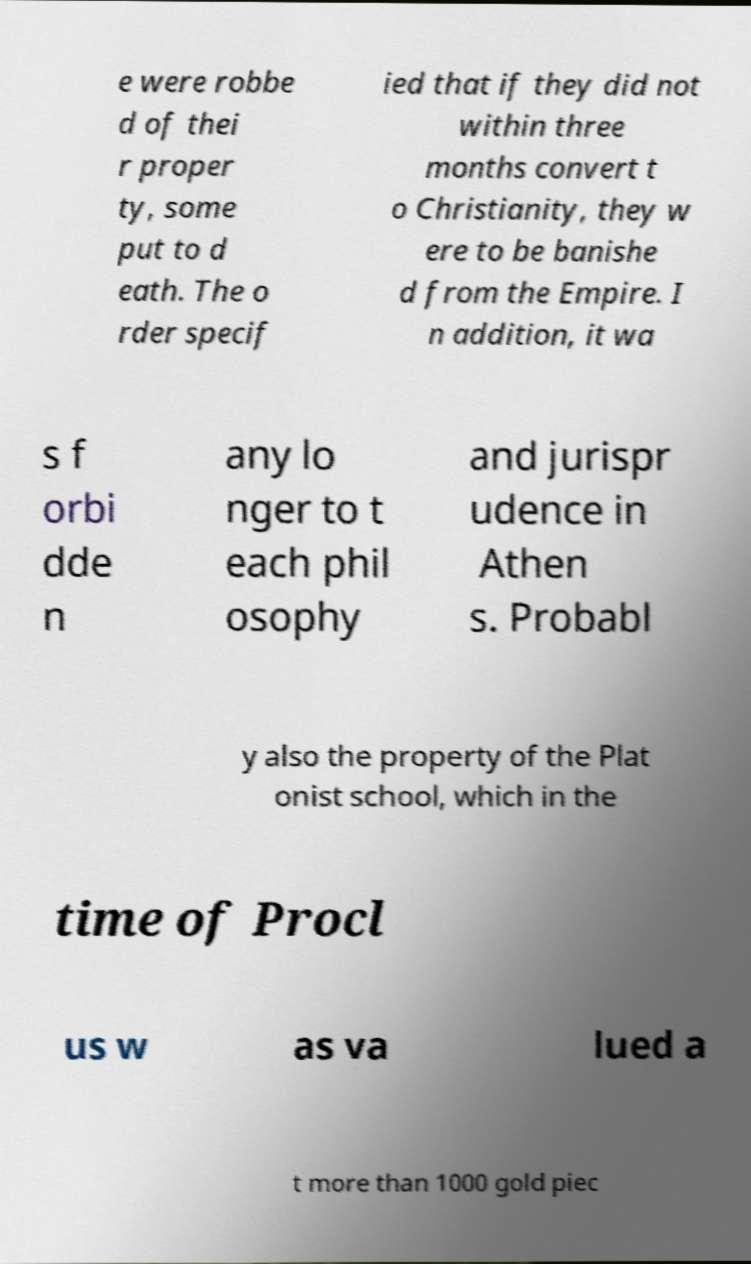Please identify and transcribe the text found in this image. e were robbe d of thei r proper ty, some put to d eath. The o rder specif ied that if they did not within three months convert t o Christianity, they w ere to be banishe d from the Empire. I n addition, it wa s f orbi dde n any lo nger to t each phil osophy and jurispr udence in Athen s. Probabl y also the property of the Plat onist school, which in the time of Procl us w as va lued a t more than 1000 gold piec 